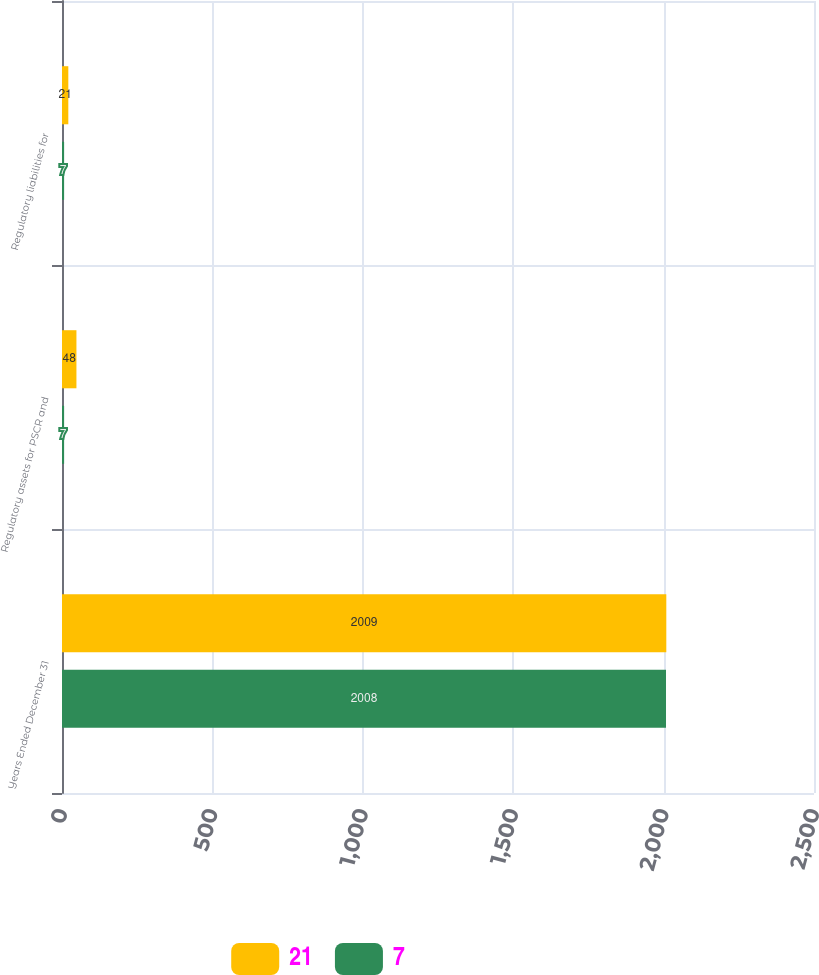Convert chart. <chart><loc_0><loc_0><loc_500><loc_500><stacked_bar_chart><ecel><fcel>Years Ended December 31<fcel>Regulatory assets for PSCR and<fcel>Regulatory liabilities for<nl><fcel>21<fcel>2009<fcel>48<fcel>21<nl><fcel>7<fcel>2008<fcel>7<fcel>7<nl></chart> 